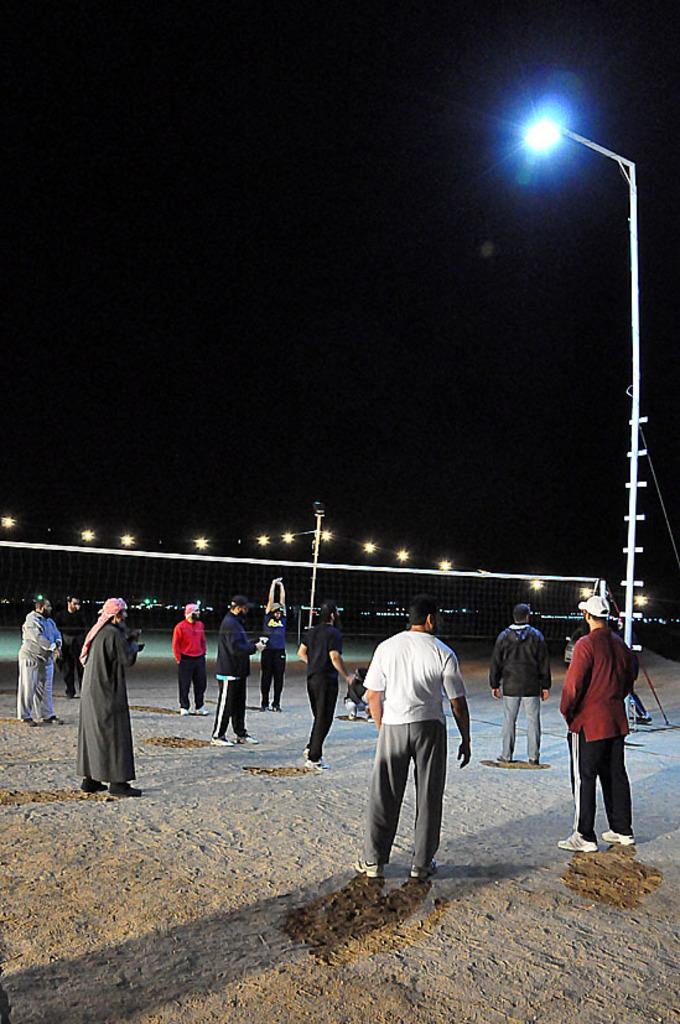What are the people in the image doing? The people in the image are standing on the ground. What structure can be seen in the image? There is a light pole in the image. What object is present in the image that might be used for catching or blocking? There is a net in the image. What can be seen in the image that might provide illumination? There are lights in the image. What is the condition of the sky in the background of the image? The sky in the background of the image is dark. What time of day is it in the image, and is there a robin present? The time of day cannot be determined from the image, and there is no robin present. 